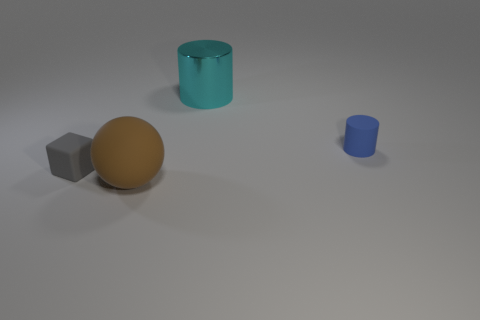What can be inferred about the setting of this image? The image appears to be a minimalist arrangement typical for demonstrating shapes and forms, perhaps for a study or with an educational intent. The setting lacks specific context, making it seem like a controlled environment like a studio or a computer-generated scene. 